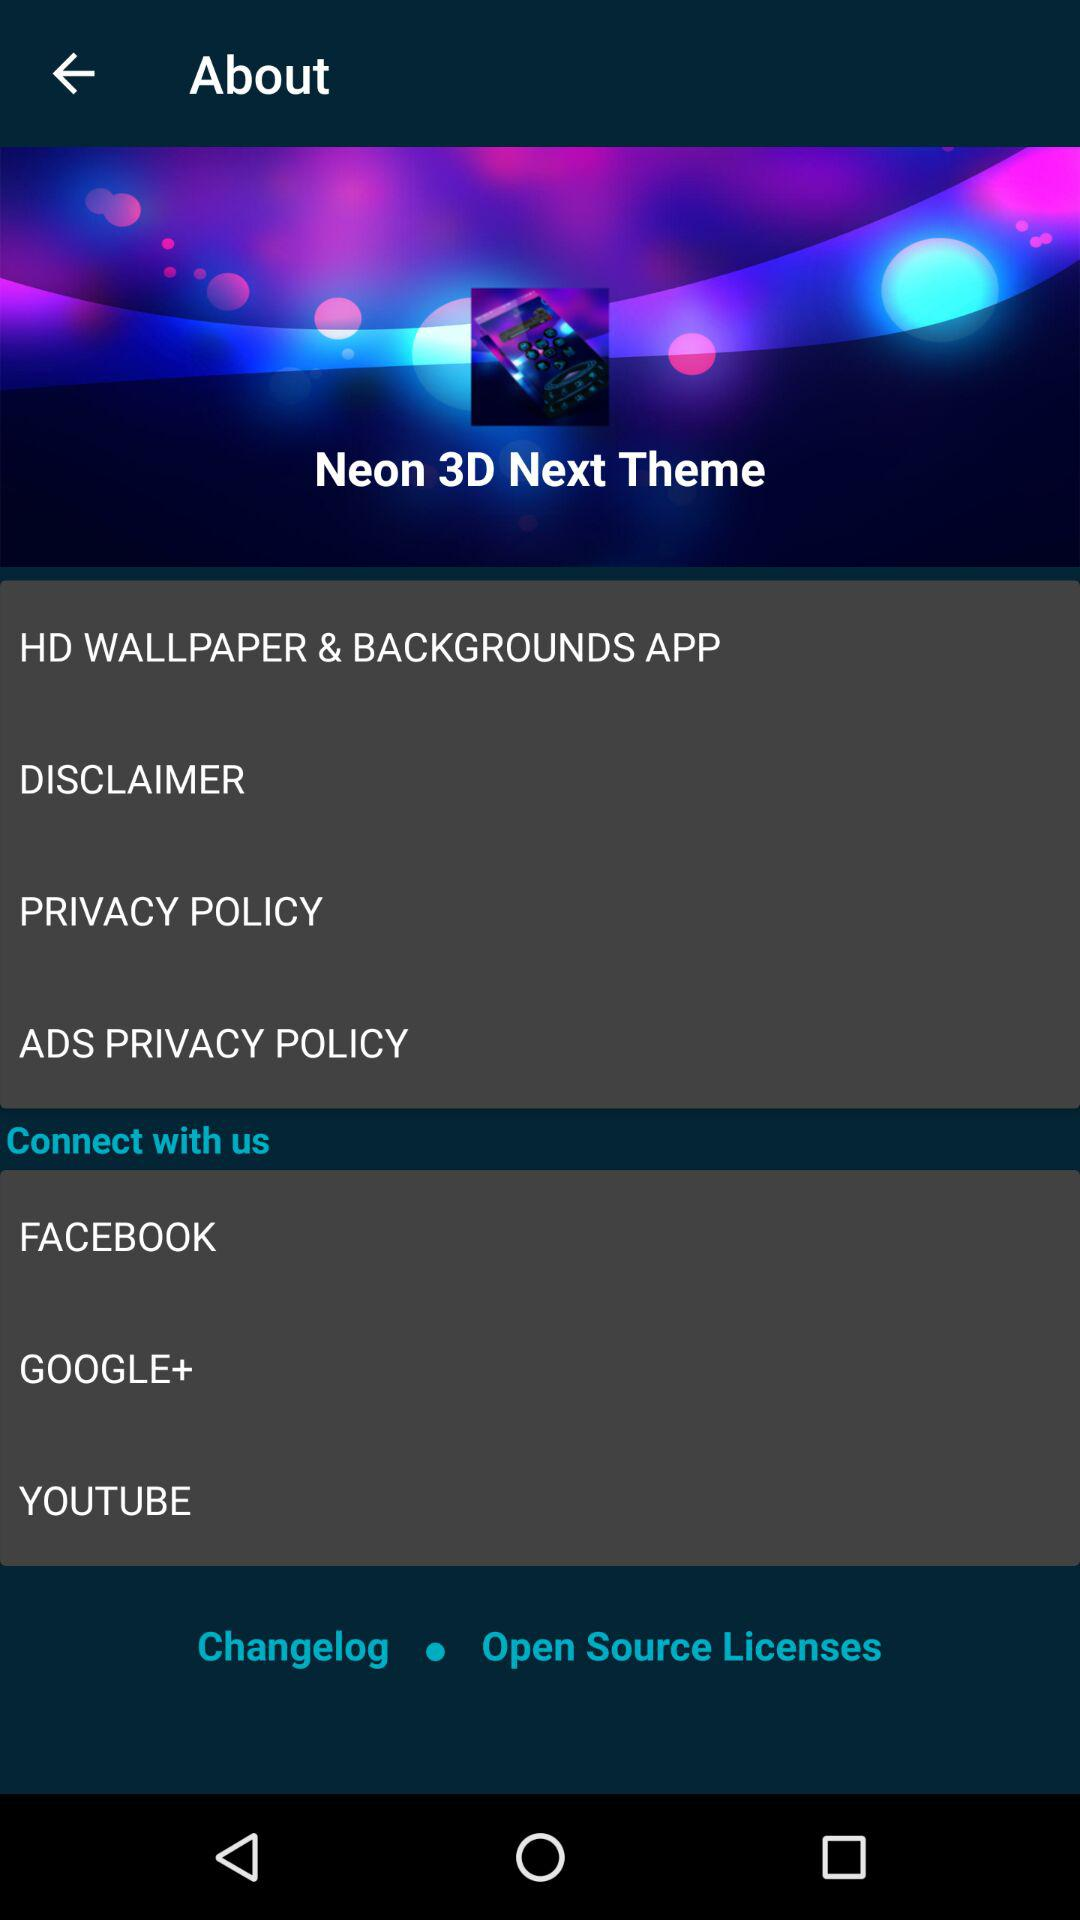What are the different options available for connecting? The different options available for connecting are "FACEBOOK", "GOOGLE+" and "YOUTUBE". 